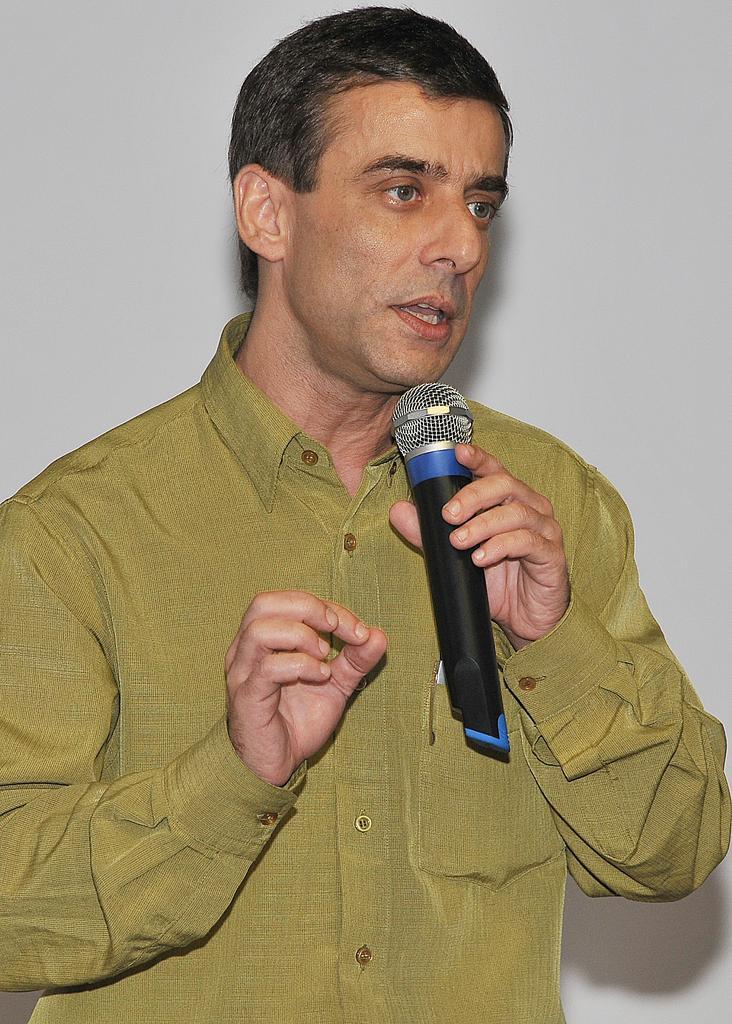Can you describe this image briefly? In the center of the image we can see a man standing and holding a mic in his hand. In the background there is a wall. 